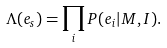<formula> <loc_0><loc_0><loc_500><loc_500>\Lambda ( e _ { s } ) = \prod _ { i } P ( e _ { i } | M , I ) .</formula> 